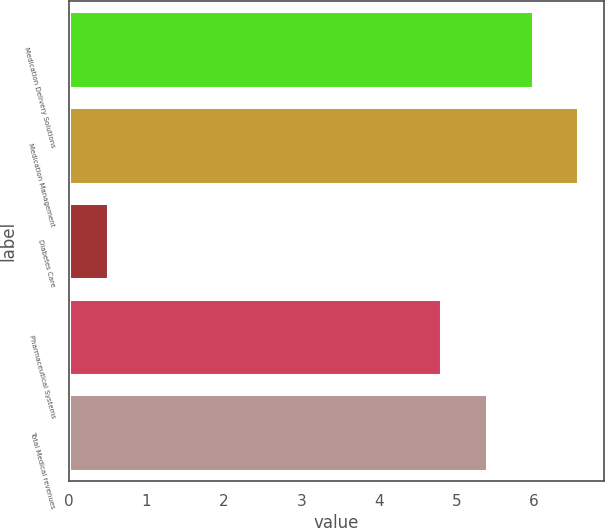Convert chart to OTSL. <chart><loc_0><loc_0><loc_500><loc_500><bar_chart><fcel>Medication Delivery Solutions<fcel>Medication Management<fcel>Diabetes Care<fcel>Pharmaceutical Systems<fcel>Total Medical revenues<nl><fcel>5.98<fcel>6.57<fcel>0.5<fcel>4.8<fcel>5.39<nl></chart> 